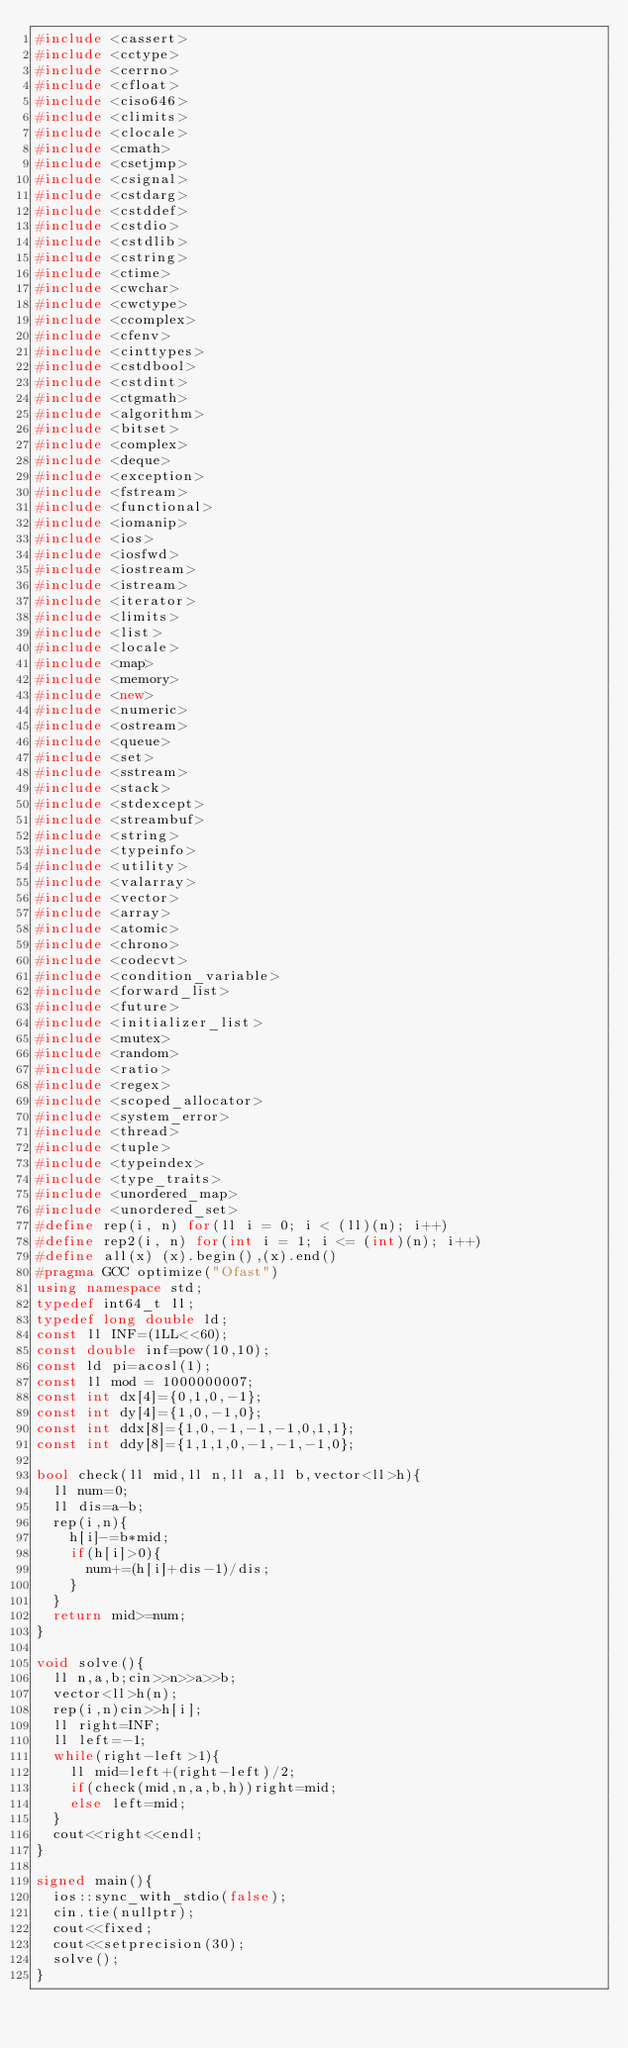<code> <loc_0><loc_0><loc_500><loc_500><_C++_>#include <cassert>
#include <cctype>
#include <cerrno>
#include <cfloat>
#include <ciso646>
#include <climits>
#include <clocale>
#include <cmath>
#include <csetjmp>
#include <csignal>
#include <cstdarg>
#include <cstddef>
#include <cstdio>
#include <cstdlib>
#include <cstring>
#include <ctime>
#include <cwchar>
#include <cwctype>
#include <ccomplex>
#include <cfenv>
#include <cinttypes>
#include <cstdbool>
#include <cstdint>
#include <ctgmath>
#include <algorithm>
#include <bitset>
#include <complex>
#include <deque>
#include <exception>
#include <fstream>
#include <functional>
#include <iomanip>
#include <ios>
#include <iosfwd>
#include <iostream>
#include <istream>
#include <iterator>
#include <limits>
#include <list>
#include <locale>
#include <map>
#include <memory>
#include <new>
#include <numeric>
#include <ostream>
#include <queue>
#include <set>
#include <sstream>
#include <stack>
#include <stdexcept>
#include <streambuf>
#include <string>
#include <typeinfo>
#include <utility>
#include <valarray>
#include <vector>
#include <array>
#include <atomic>
#include <chrono>
#include <codecvt>
#include <condition_variable>
#include <forward_list>
#include <future>
#include <initializer_list>
#include <mutex>
#include <random>
#include <ratio>
#include <regex>
#include <scoped_allocator>
#include <system_error>
#include <thread>
#include <tuple>
#include <typeindex>
#include <type_traits>
#include <unordered_map>
#include <unordered_set>
#define rep(i, n) for(ll i = 0; i < (ll)(n); i++)
#define rep2(i, n) for(int i = 1; i <= (int)(n); i++)
#define all(x) (x).begin(),(x).end()
#pragma GCC optimize("Ofast")
using namespace std;
typedef int64_t ll;
typedef long double ld;
const ll INF=(1LL<<60);
const double inf=pow(10,10);
const ld pi=acosl(1);
const ll mod = 1000000007;
const int dx[4]={0,1,0,-1};
const int dy[4]={1,0,-1,0};
const int ddx[8]={1,0,-1,-1,-1,0,1,1};
const int ddy[8]={1,1,1,0,-1,-1,-1,0};

bool check(ll mid,ll n,ll a,ll b,vector<ll>h){
  ll num=0;
  ll dis=a-b;
  rep(i,n){
    h[i]-=b*mid;
    if(h[i]>0){
      num+=(h[i]+dis-1)/dis;
    }
  }
  return mid>=num;
}

void solve(){
  ll n,a,b;cin>>n>>a>>b;
  vector<ll>h(n);
  rep(i,n)cin>>h[i];
  ll right=INF;
  ll left=-1;
  while(right-left>1){
    ll mid=left+(right-left)/2;
    if(check(mid,n,a,b,h))right=mid;
    else left=mid;
  }
  cout<<right<<endl;
}

signed main(){
	ios::sync_with_stdio(false);
	cin.tie(nullptr);
	cout<<fixed;
	cout<<setprecision(30);
	solve();
}
</code> 